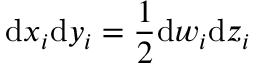Convert formula to latex. <formula><loc_0><loc_0><loc_500><loc_500>d x _ { i } d y _ { i } = \frac { 1 } { 2 } d w _ { i } d z _ { i }</formula> 